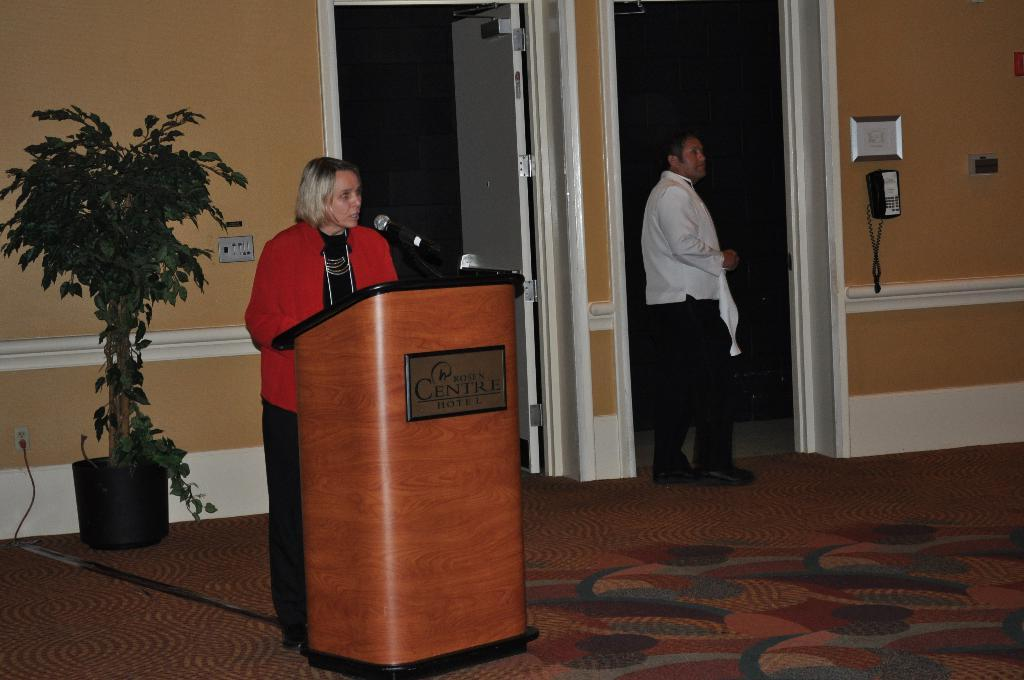How many people are present in the image? There are two people on the ground in the image. What object can be seen in front of the people? There is a podium in the image. What device is used for amplifying sound in the image? There is a microphone in the image. What can be seen in the background of the image? There is a wall, a house plant, and a telephone in the background of the image. What type of humor can be seen in the plants in the image? There are no plants present in the image, and therefore no humor can be observed in them. 